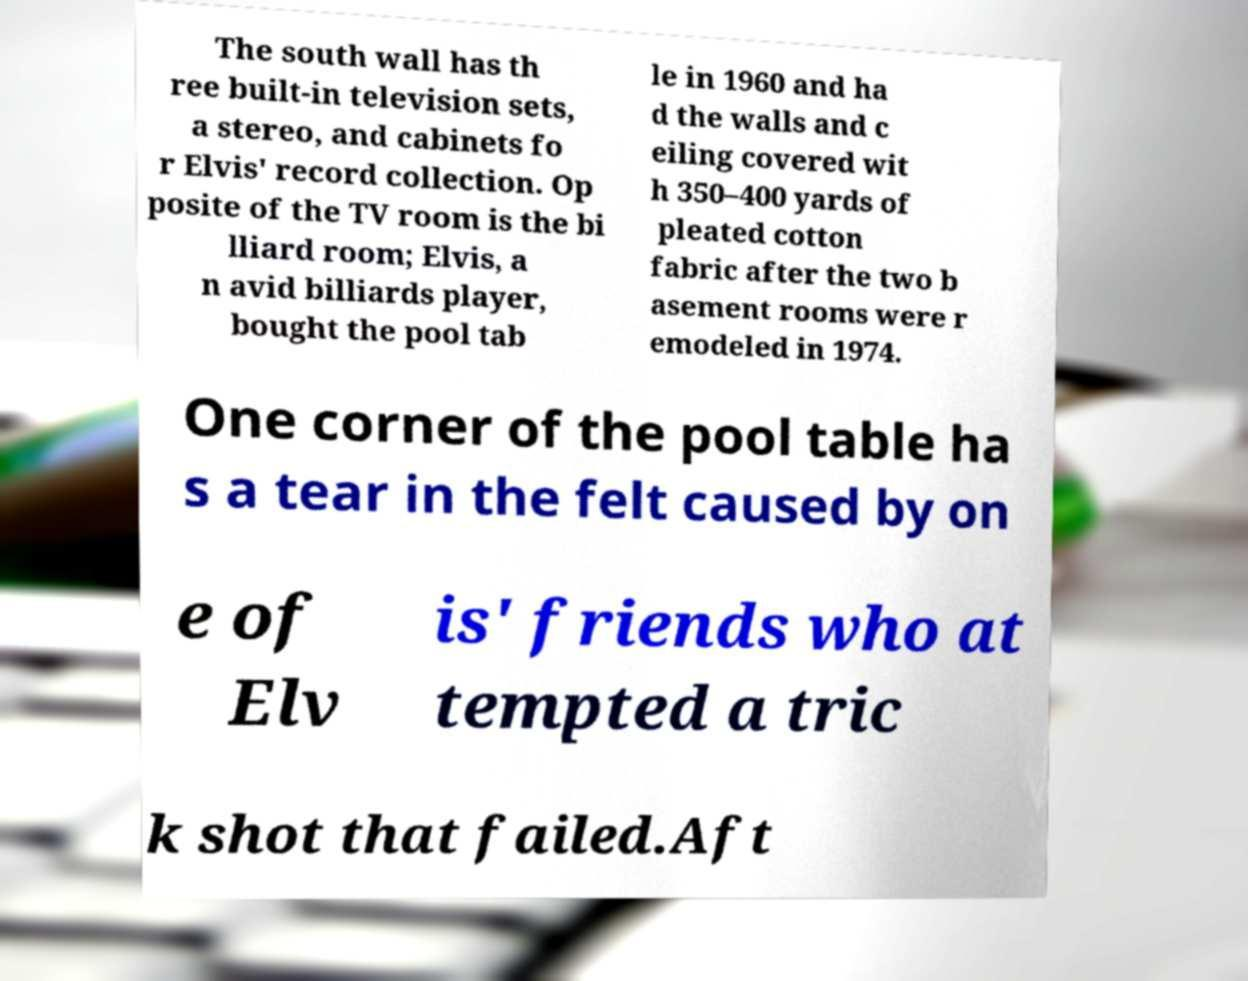Could you extract and type out the text from this image? The south wall has th ree built-in television sets, a stereo, and cabinets fo r Elvis' record collection. Op posite of the TV room is the bi lliard room; Elvis, a n avid billiards player, bought the pool tab le in 1960 and ha d the walls and c eiling covered wit h 350–400 yards of pleated cotton fabric after the two b asement rooms were r emodeled in 1974. One corner of the pool table ha s a tear in the felt caused by on e of Elv is' friends who at tempted a tric k shot that failed.Aft 